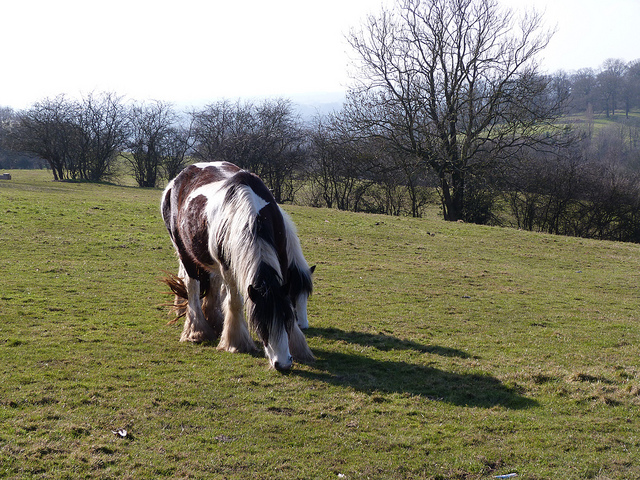What breed of horse is in the picture? The horse in the picture looks like a Shetland pony, known for its compact size and sturdy build. 